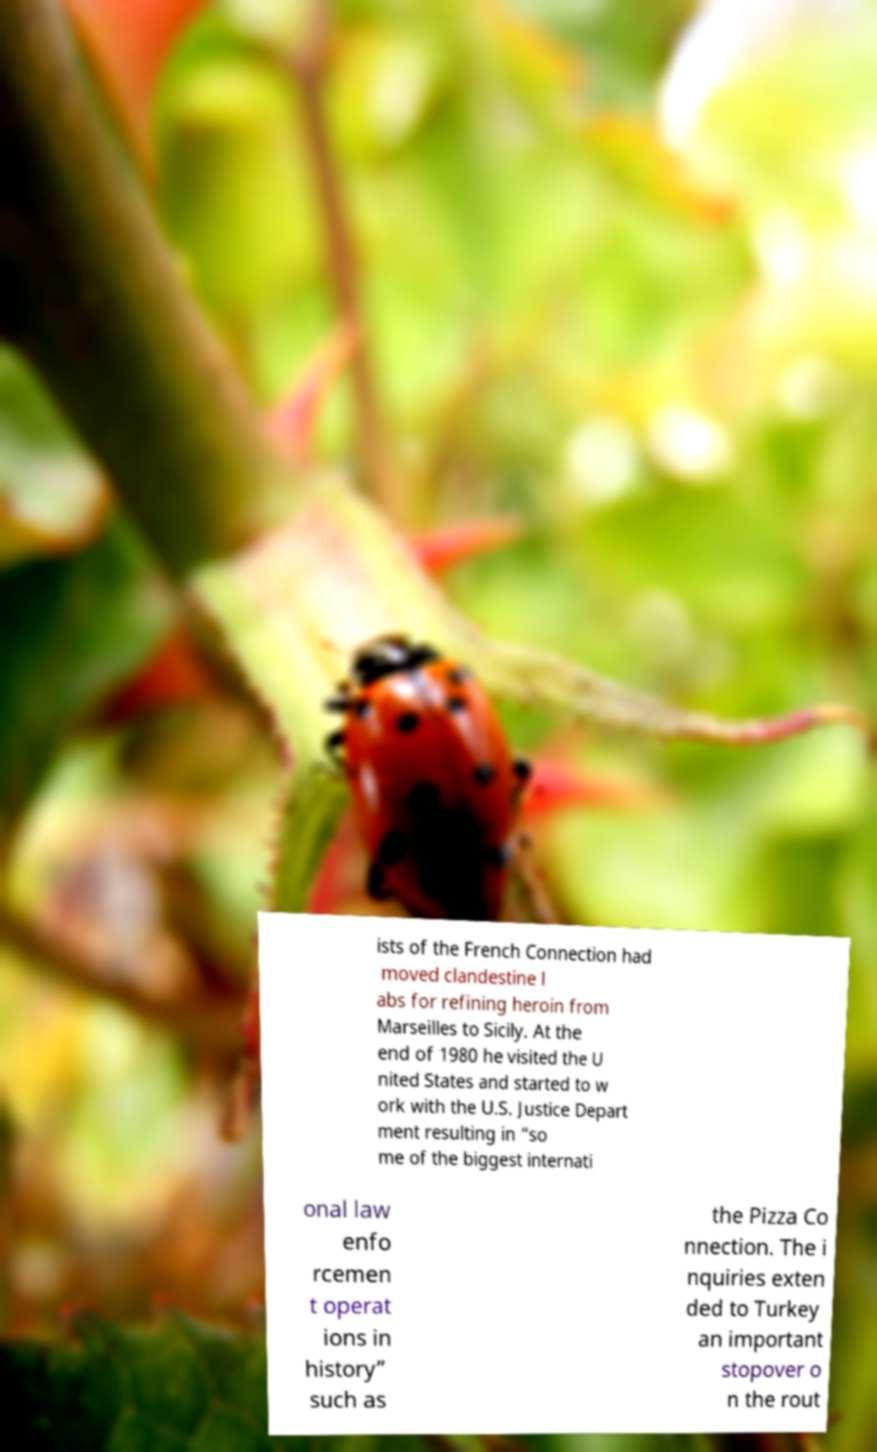What messages or text are displayed in this image? I need them in a readable, typed format. ists of the French Connection had moved clandestine l abs for refining heroin from Marseilles to Sicily. At the end of 1980 he visited the U nited States and started to w ork with the U.S. Justice Depart ment resulting in “so me of the biggest internati onal law enfo rcemen t operat ions in history” such as the Pizza Co nnection. The i nquiries exten ded to Turkey an important stopover o n the rout 